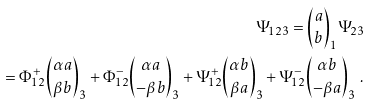<formula> <loc_0><loc_0><loc_500><loc_500>\Psi _ { 1 2 3 } = { a \choose b } _ { 1 } \Psi _ { 2 3 } \\ = \Phi ^ { + } _ { 1 2 } { \alpha a \choose \beta b } _ { 3 } + \Phi ^ { - } _ { 1 2 } { \alpha a \choose - \beta b } _ { 3 } + \Psi ^ { + } _ { 1 2 } { \alpha b \choose \beta a } _ { 3 } + \Psi ^ { - } _ { 1 2 } { \alpha b \choose - \beta a } _ { 3 } \ .</formula> 